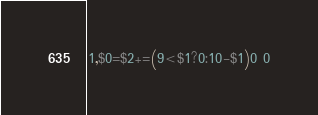<code> <loc_0><loc_0><loc_500><loc_500><_Awk_>1,$0=$2+=(9<$1?0:10-$1)0 0</code> 